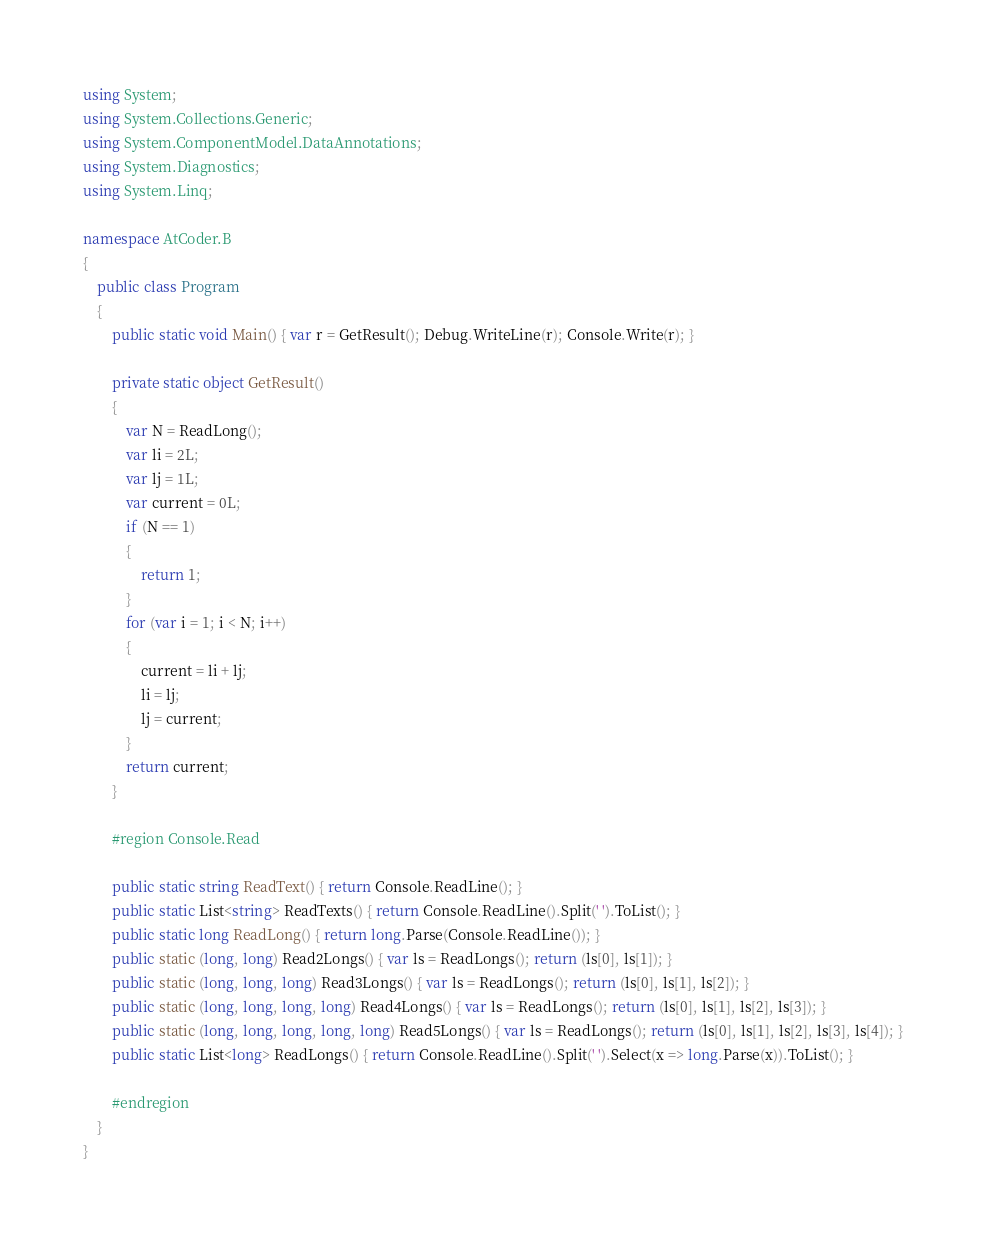<code> <loc_0><loc_0><loc_500><loc_500><_C#_>using System;
using System.Collections.Generic;
using System.ComponentModel.DataAnnotations;
using System.Diagnostics;
using System.Linq;

namespace AtCoder.B
{
    public class Program
    {
        public static void Main() { var r = GetResult(); Debug.WriteLine(r); Console.Write(r); }

        private static object GetResult()
        {
            var N = ReadLong();
            var li = 2L;
            var lj = 1L;
            var current = 0L;
            if (N == 1)
            {
                return 1;
            }
            for (var i = 1; i < N; i++)
            {
                current = li + lj;
                li = lj;
                lj = current;
            }
            return current;
        }

        #region Console.Read

        public static string ReadText() { return Console.ReadLine(); }
        public static List<string> ReadTexts() { return Console.ReadLine().Split(' ').ToList(); }
        public static long ReadLong() { return long.Parse(Console.ReadLine()); }
        public static (long, long) Read2Longs() { var ls = ReadLongs(); return (ls[0], ls[1]); }
        public static (long, long, long) Read3Longs() { var ls = ReadLongs(); return (ls[0], ls[1], ls[2]); }
        public static (long, long, long, long) Read4Longs() { var ls = ReadLongs(); return (ls[0], ls[1], ls[2], ls[3]); }
        public static (long, long, long, long, long) Read5Longs() { var ls = ReadLongs(); return (ls[0], ls[1], ls[2], ls[3], ls[4]); }
        public static List<long> ReadLongs() { return Console.ReadLine().Split(' ').Select(x => long.Parse(x)).ToList(); }

        #endregion
    }
}
</code> 